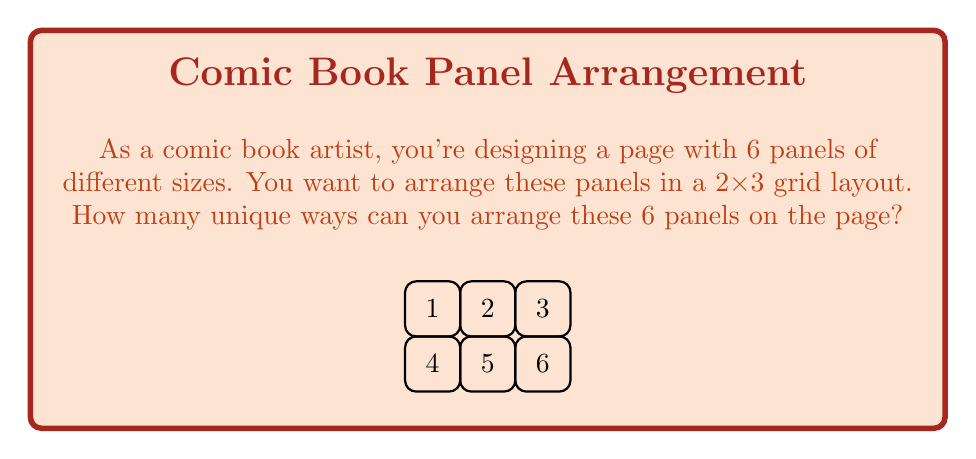Provide a solution to this math problem. To solve this problem, we'll use the concept of permutations from combinatorics.

1) First, we need to recognize that this is a permutation problem. We are arranging 6 distinct panels in 6 distinct positions.

2) The formula for permutations of n distinct objects is:

   $$P(n) = n!$$

   where $n!$ represents the factorial of n.

3) In this case, $n = 6$, so we need to calculate $6!$

4) Let's expand this:
   $$6! = 6 \times 5 \times 4 \times 3 \times 2 \times 1$$

5) Calculating this:
   $$6! = 720$$

Therefore, there are 720 unique ways to arrange the 6 panels on the page.

This large number illustrates the vast creative possibilities in comic book layout design, even with a simple 2x3 grid. Each arrangement could potentially change the flow and impact of the story, allowing for artistic expression through panel placement.
Answer: 720 